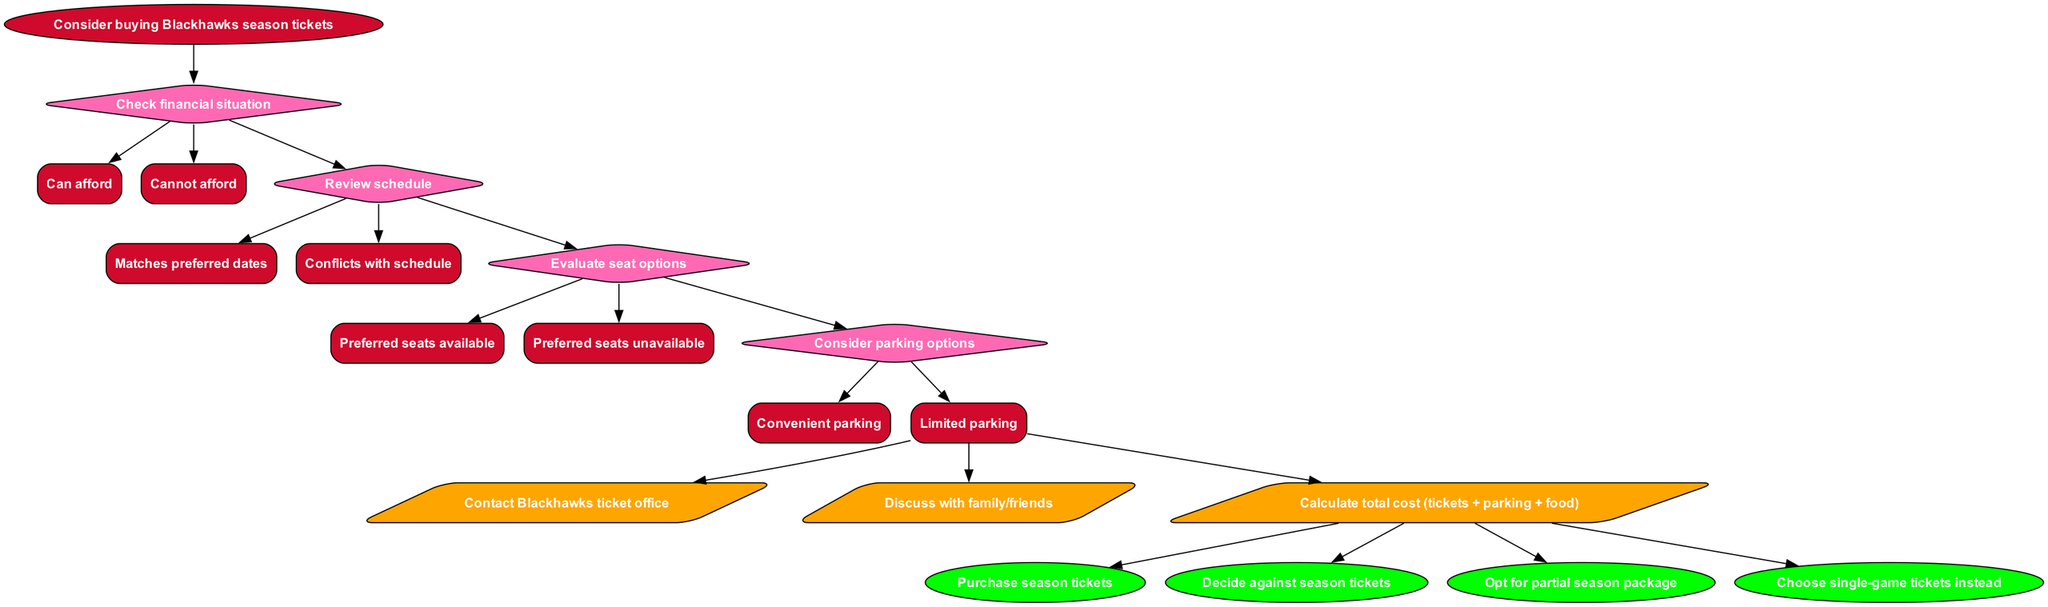What is the starting point of the decision flow? The diagram begins with the node labeled "Consider buying Blackhawks season tickets," which marks the initial decision-making point.
Answer: Consider buying Blackhawks season tickets How many decision nodes are there in the flowchart? There are four decision nodes listed in the diagram: checking financial situation, reviewing schedule, evaluating seat options, and considering parking options.
Answer: 4 What are the two options under the node "Check financial situation"? The options under this decision node are "Can afford" and "Cannot afford," indicating the financial viability of purchasing season tickets.
Answer: Can afford, Cannot afford Which action is linked to the last decision node? The last decision leads to the action nodes, where options are provided to take actions like contacting the ticket office; specifically, the last decision node leads to discussing with family/friends.
Answer: Discuss with family/friends If someone checks their financial situation and can afford tickets, what should they do next? If a person can afford season tickets, they can proceed to the next decision node, which is to review the schedule for preferred match dates. This links the financial decision to the schedule review.
Answer: Review schedule What happens if preferred seats are unavailable? If preferred seats are unavailable after evaluating seat options, this will lead the individual to potentially consider options like opting for a partial season package or choosing single-game tickets.
Answer: Opt for partial season package, Choose single-game tickets instead How are the actions categorized in the diagram? The actions are categorized under a specific section following the last decision node, where they are represented by parallelogram shapes, indicating steps to take after making the decisions.
Answer: Actions What color represents the end nodes of the flowchart? The end nodes of the flowchart are represented in green, indicating the final outcomes of the decision-making process.
Answer: Green How many end nodes are available to choose from? There are four distinct end nodes representing different outcomes based on the decisions made—such as purchasing or deciding against tickets.
Answer: 4 